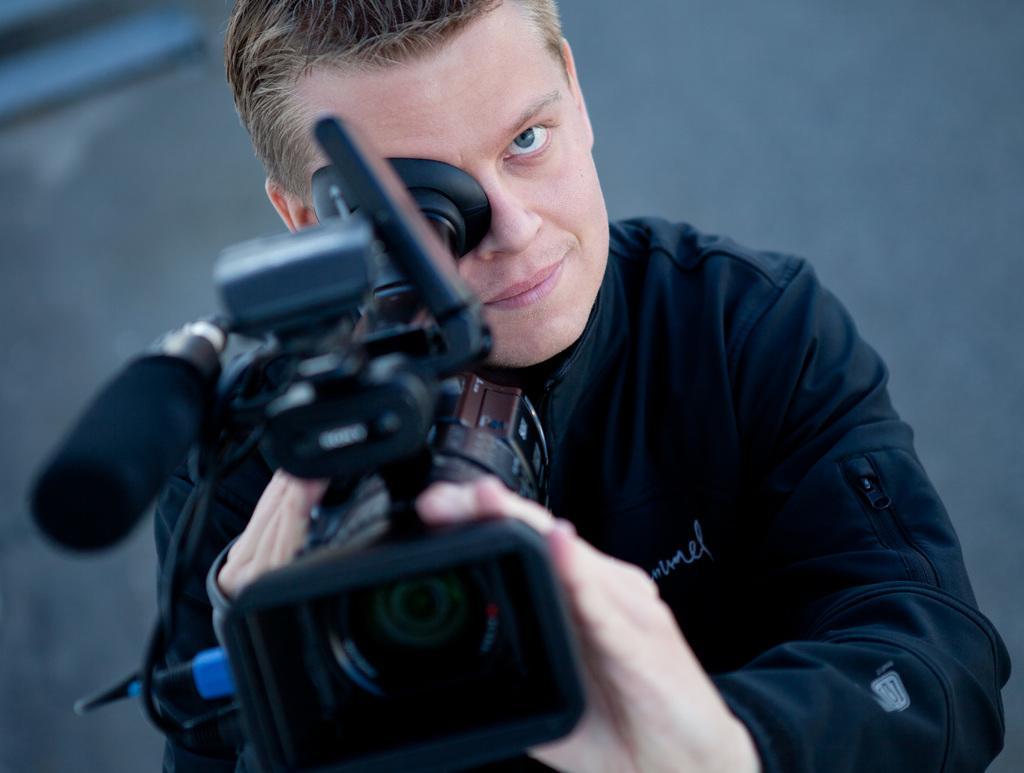Describe this image in one or two sentences. In the image a man is standing and holding a camera. Behind him there is a wall. 